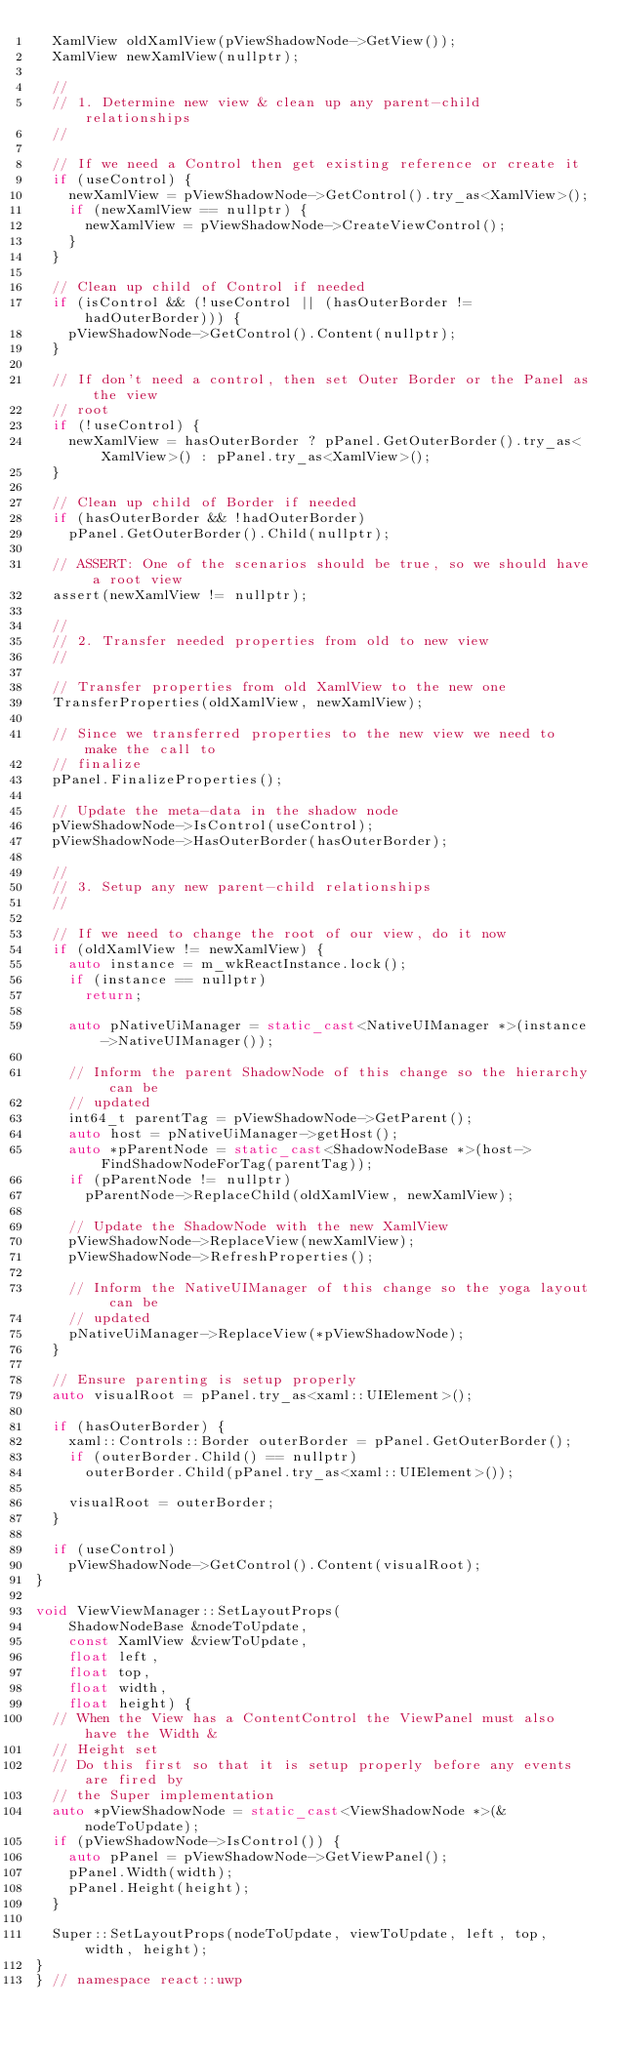Convert code to text. <code><loc_0><loc_0><loc_500><loc_500><_C++_>  XamlView oldXamlView(pViewShadowNode->GetView());
  XamlView newXamlView(nullptr);

  //
  // 1. Determine new view & clean up any parent-child relationships
  //

  // If we need a Control then get existing reference or create it
  if (useControl) {
    newXamlView = pViewShadowNode->GetControl().try_as<XamlView>();
    if (newXamlView == nullptr) {
      newXamlView = pViewShadowNode->CreateViewControl();
    }
  }

  // Clean up child of Control if needed
  if (isControl && (!useControl || (hasOuterBorder != hadOuterBorder))) {
    pViewShadowNode->GetControl().Content(nullptr);
  }

  // If don't need a control, then set Outer Border or the Panel as the view
  // root
  if (!useControl) {
    newXamlView = hasOuterBorder ? pPanel.GetOuterBorder().try_as<XamlView>() : pPanel.try_as<XamlView>();
  }

  // Clean up child of Border if needed
  if (hasOuterBorder && !hadOuterBorder)
    pPanel.GetOuterBorder().Child(nullptr);

  // ASSERT: One of the scenarios should be true, so we should have a root view
  assert(newXamlView != nullptr);

  //
  // 2. Transfer needed properties from old to new view
  //

  // Transfer properties from old XamlView to the new one
  TransferProperties(oldXamlView, newXamlView);

  // Since we transferred properties to the new view we need to make the call to
  // finalize
  pPanel.FinalizeProperties();

  // Update the meta-data in the shadow node
  pViewShadowNode->IsControl(useControl);
  pViewShadowNode->HasOuterBorder(hasOuterBorder);

  //
  // 3. Setup any new parent-child relationships
  //

  // If we need to change the root of our view, do it now
  if (oldXamlView != newXamlView) {
    auto instance = m_wkReactInstance.lock();
    if (instance == nullptr)
      return;

    auto pNativeUiManager = static_cast<NativeUIManager *>(instance->NativeUIManager());

    // Inform the parent ShadowNode of this change so the hierarchy can be
    // updated
    int64_t parentTag = pViewShadowNode->GetParent();
    auto host = pNativeUiManager->getHost();
    auto *pParentNode = static_cast<ShadowNodeBase *>(host->FindShadowNodeForTag(parentTag));
    if (pParentNode != nullptr)
      pParentNode->ReplaceChild(oldXamlView, newXamlView);

    // Update the ShadowNode with the new XamlView
    pViewShadowNode->ReplaceView(newXamlView);
    pViewShadowNode->RefreshProperties();

    // Inform the NativeUIManager of this change so the yoga layout can be
    // updated
    pNativeUiManager->ReplaceView(*pViewShadowNode);
  }

  // Ensure parenting is setup properly
  auto visualRoot = pPanel.try_as<xaml::UIElement>();

  if (hasOuterBorder) {
    xaml::Controls::Border outerBorder = pPanel.GetOuterBorder();
    if (outerBorder.Child() == nullptr)
      outerBorder.Child(pPanel.try_as<xaml::UIElement>());

    visualRoot = outerBorder;
  }

  if (useControl)
    pViewShadowNode->GetControl().Content(visualRoot);
}

void ViewViewManager::SetLayoutProps(
    ShadowNodeBase &nodeToUpdate,
    const XamlView &viewToUpdate,
    float left,
    float top,
    float width,
    float height) {
  // When the View has a ContentControl the ViewPanel must also have the Width &
  // Height set
  // Do this first so that it is setup properly before any events are fired by
  // the Super implementation
  auto *pViewShadowNode = static_cast<ViewShadowNode *>(&nodeToUpdate);
  if (pViewShadowNode->IsControl()) {
    auto pPanel = pViewShadowNode->GetViewPanel();
    pPanel.Width(width);
    pPanel.Height(height);
  }

  Super::SetLayoutProps(nodeToUpdate, viewToUpdate, left, top, width, height);
}
} // namespace react::uwp
</code> 